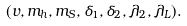Convert formula to latex. <formula><loc_0><loc_0><loc_500><loc_500>( v , m _ { h } , m _ { S } , \delta _ { 1 } , \delta _ { 2 } , \lambda _ { 2 } , \lambda _ { L } ) .</formula> 